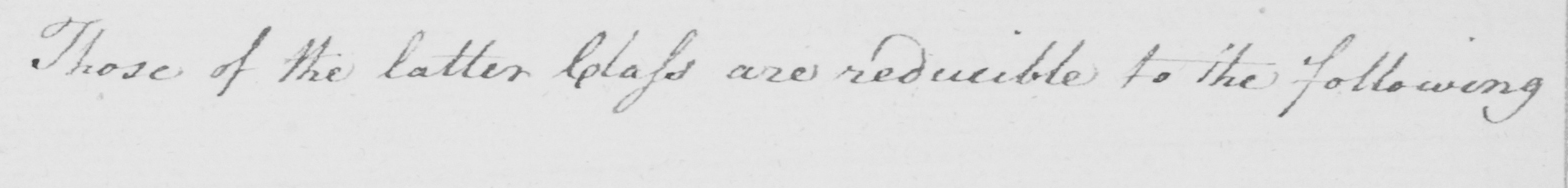Please provide the text content of this handwritten line. Those of the latter Class are reducible to the following 